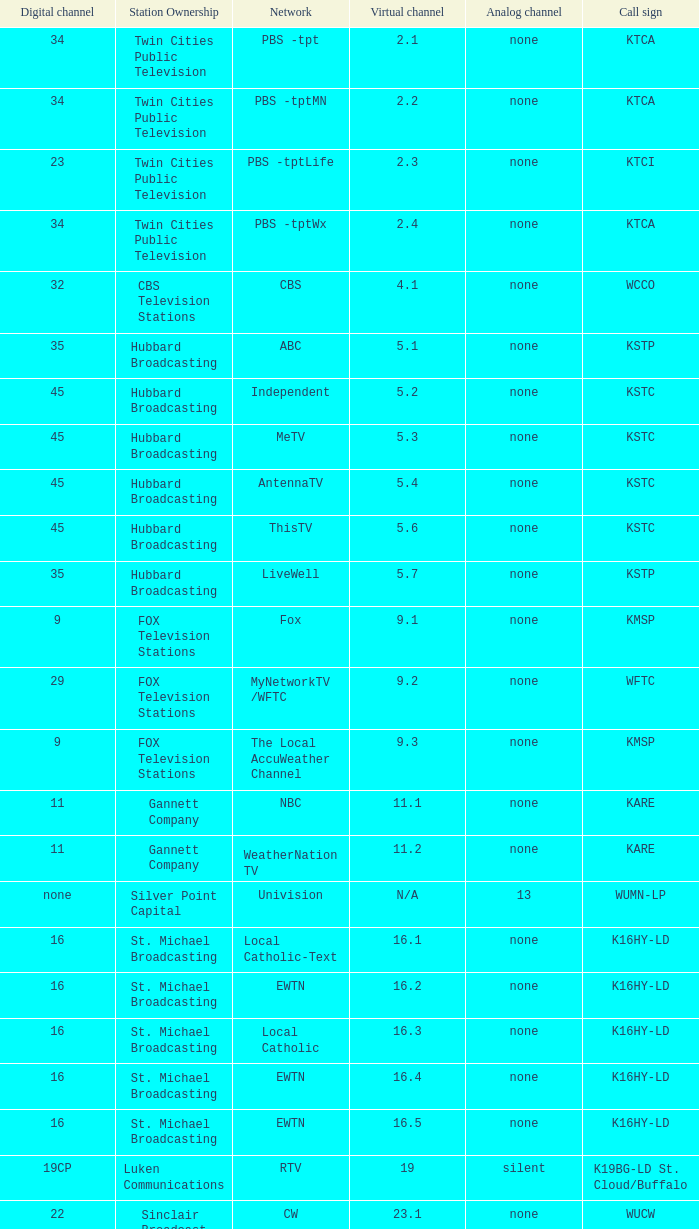Station Ownership of eicb tv, and a Call sign of ktcj-ld is what virtual network? 50.1. 